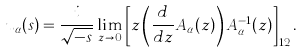Convert formula to latex. <formula><loc_0><loc_0><loc_500><loc_500>u _ { \alpha } ( s ) = \frac { i } { \sqrt { - s } } \lim _ { z \to 0 } \left [ z \left ( \frac { d } { d z } A _ { \alpha } ( z ) \right ) A _ { \alpha } ^ { - 1 } ( z ) \right ] _ { 1 2 } .</formula> 